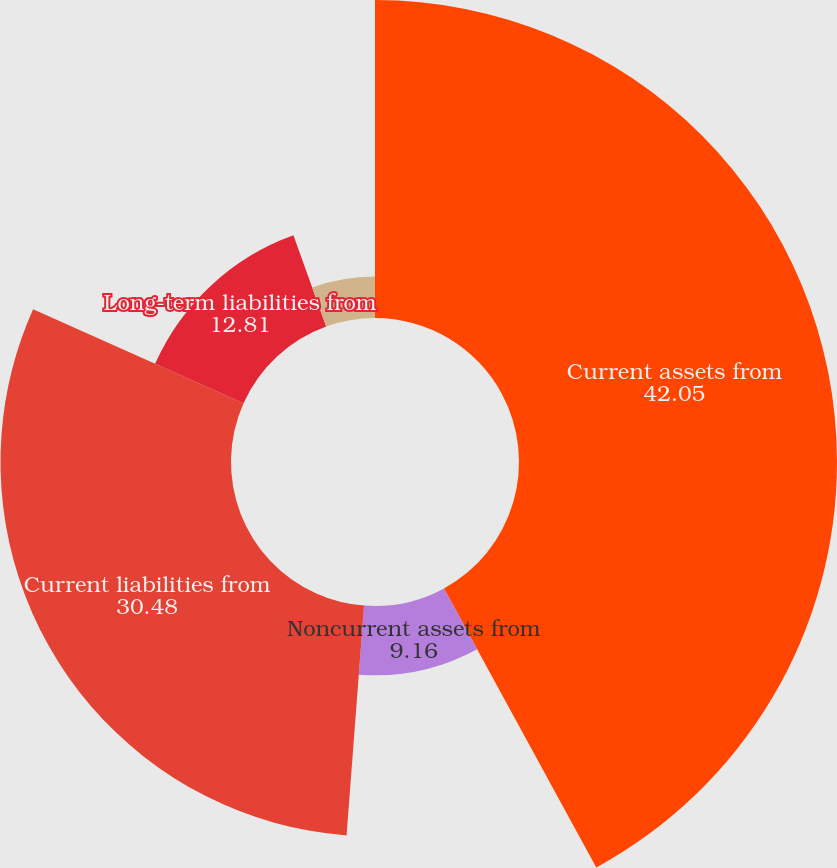Convert chart. <chart><loc_0><loc_0><loc_500><loc_500><pie_chart><fcel>Current assets from<fcel>Noncurrent assets from<fcel>Current liabilities from<fcel>Long-term liabilities from<fcel>Net assets from discontinued<nl><fcel>42.05%<fcel>9.16%<fcel>30.48%<fcel>12.81%<fcel>5.5%<nl></chart> 